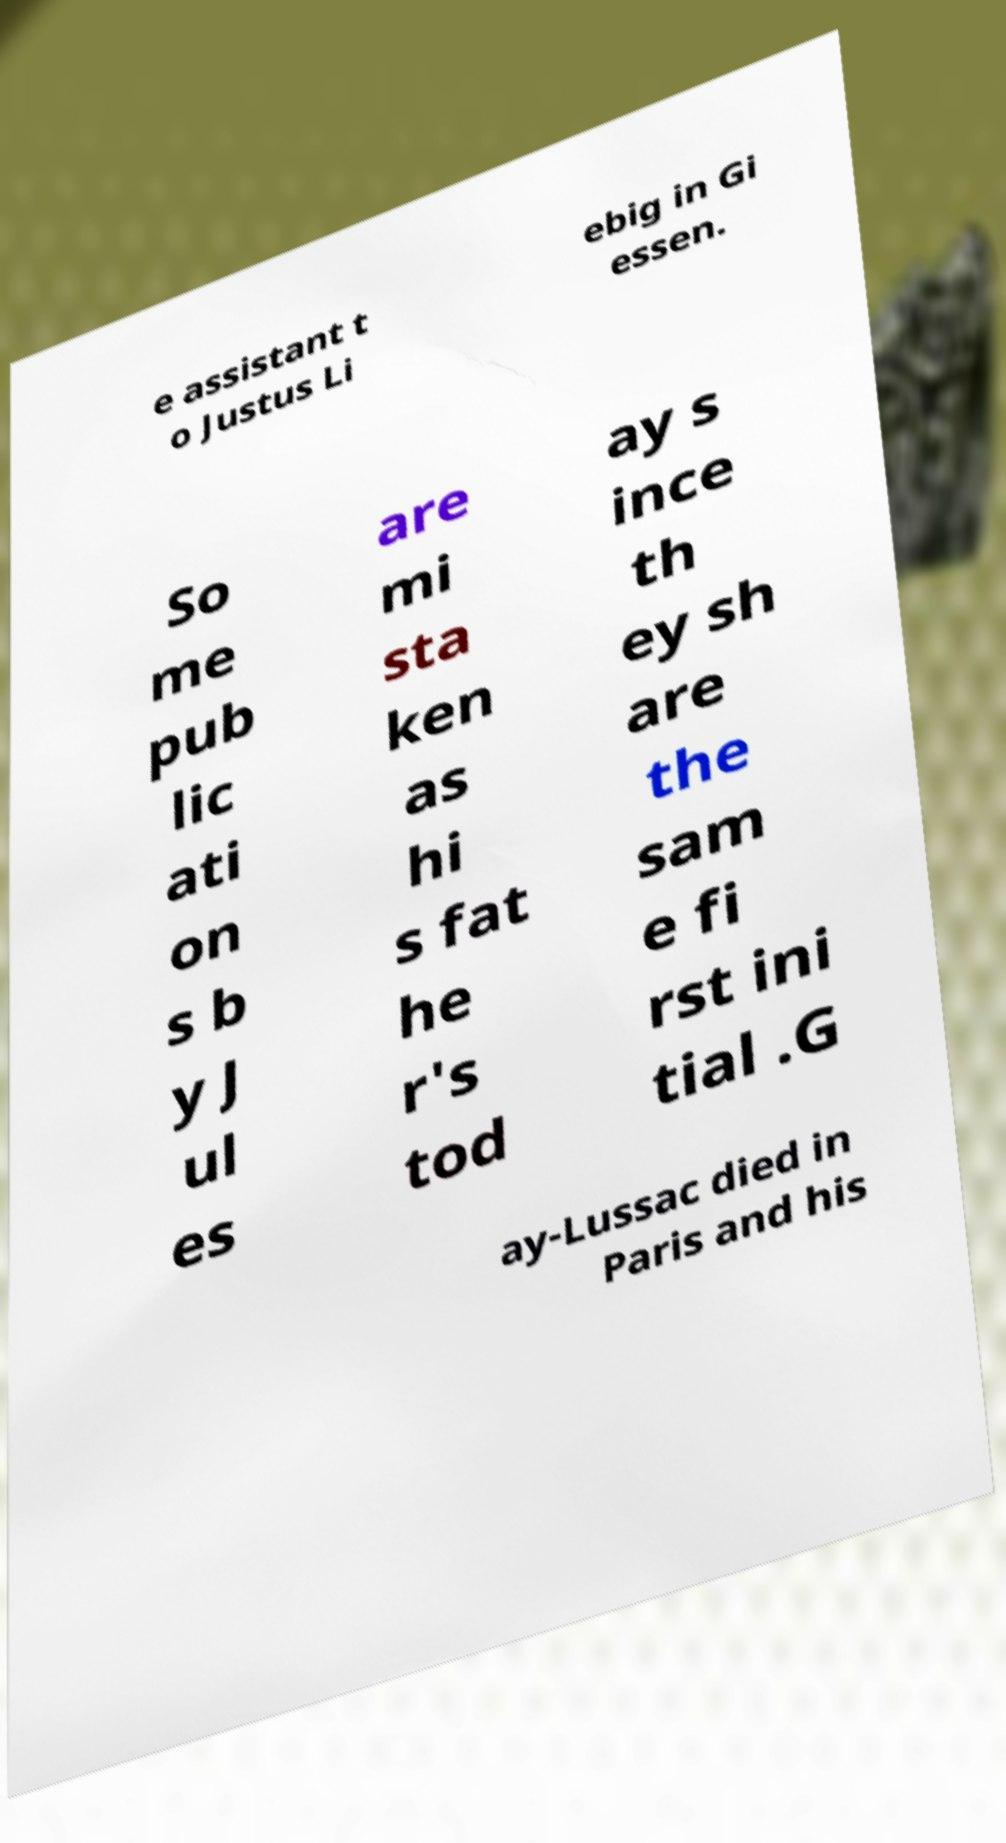For documentation purposes, I need the text within this image transcribed. Could you provide that? e assistant t o Justus Li ebig in Gi essen. So me pub lic ati on s b y J ul es are mi sta ken as hi s fat he r's tod ay s ince th ey sh are the sam e fi rst ini tial .G ay-Lussac died in Paris and his 